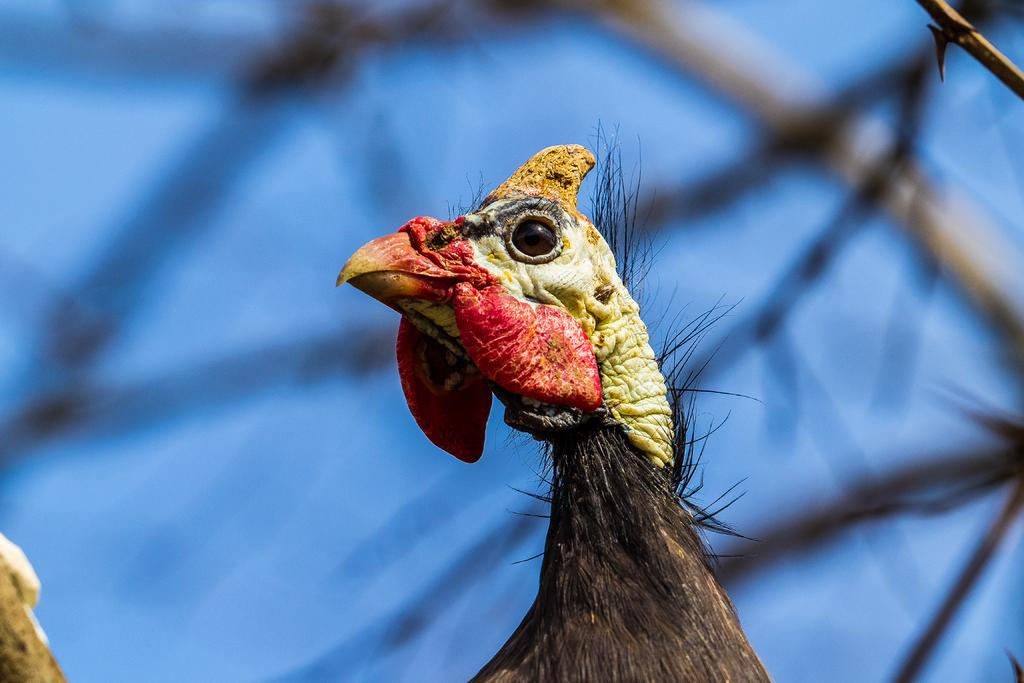What type of animal can be seen in the picture? There is a bird in the picture. What can be seen in the background of the picture? There are sticks and the sky visible in the background of the picture. How would you describe the quality of the image? The image is blurry. How many bikes are being used by the bird in the picture? There are no bikes present in the image, as it features a bird and sticks in the background. 